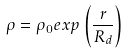Convert formula to latex. <formula><loc_0><loc_0><loc_500><loc_500>\rho = \rho _ { 0 } e x p \left ( \frac { r } { R _ { d } } \right )</formula> 